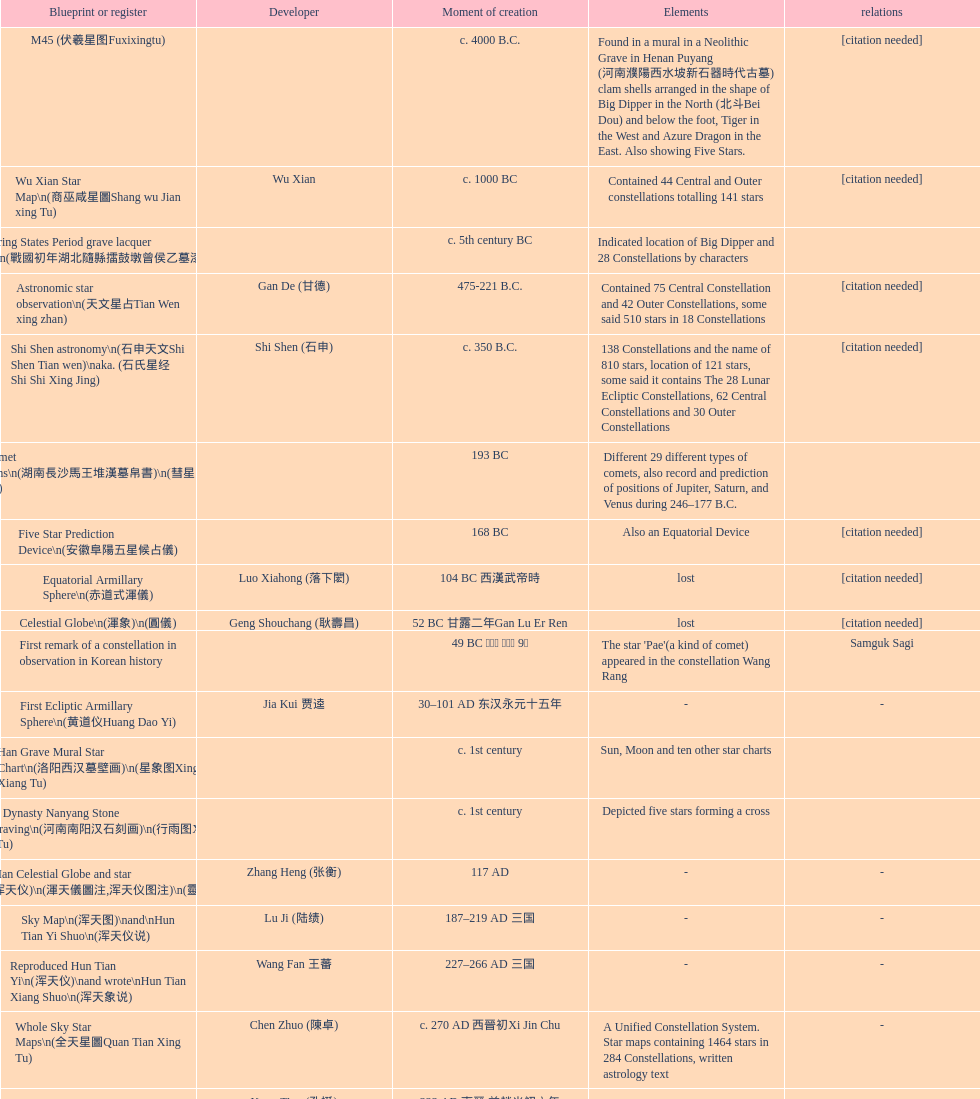Name three items created not long after the equatorial armillary sphere. Celestial Globe (渾象) (圓儀), First remark of a constellation in observation in Korean history, First Ecliptic Armillary Sphere (黄道仪Huang Dao Yi). 